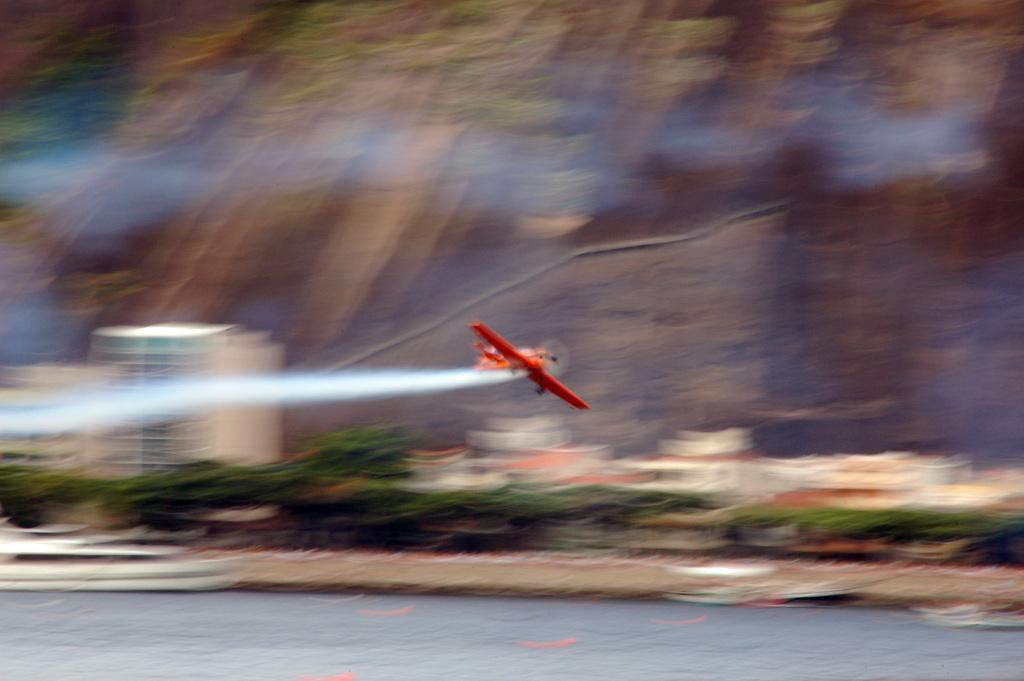What is the main subject of the image? The main subject of the image is an airplane. Can you describe the position of the airplane in the image? The airplane is in the air in the image. What natural feature can be seen in the image? There is a river visible in the image. How would you describe the background of the image? The background of the image is blurry. What type of snail can be seen crawling on the airplane in the image? There is no snail present on the airplane in the image. What substance is being used to touch the airplane in the image? There is no indication of anyone or anything touching the airplane in the image. 